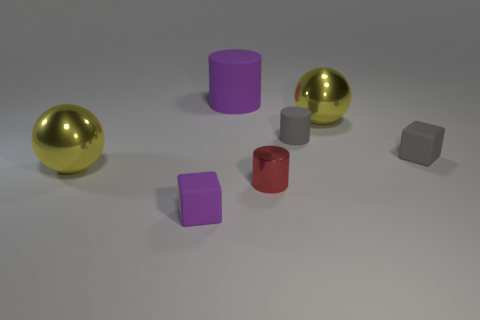Add 2 metallic balls. How many objects exist? 9 Subtract all cylinders. How many objects are left? 4 Subtract 0 cyan spheres. How many objects are left? 7 Subtract all tiny blue metal cylinders. Subtract all big rubber cylinders. How many objects are left? 6 Add 5 red cylinders. How many red cylinders are left? 6 Add 1 cubes. How many cubes exist? 3 